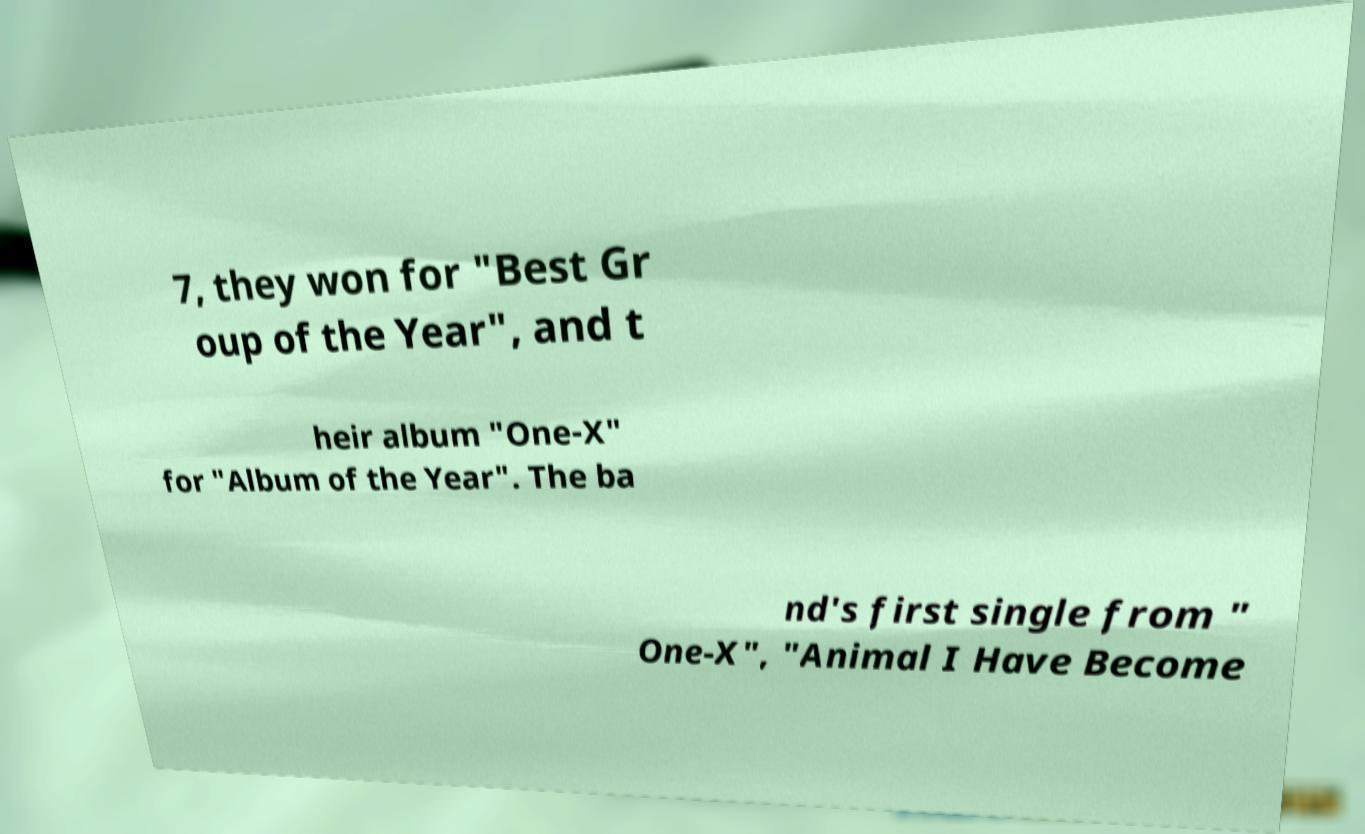Please identify and transcribe the text found in this image. 7, they won for "Best Gr oup of the Year", and t heir album "One-X" for "Album of the Year". The ba nd's first single from " One-X", "Animal I Have Become 